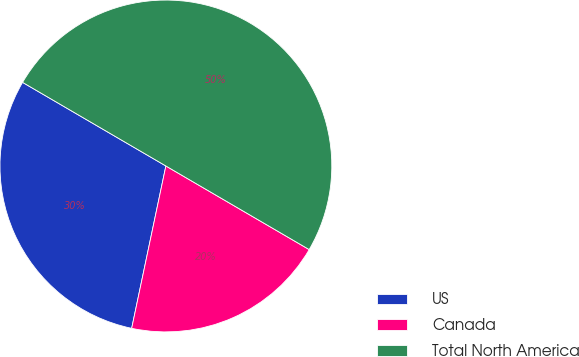<chart> <loc_0><loc_0><loc_500><loc_500><pie_chart><fcel>US<fcel>Canada<fcel>Total North America<nl><fcel>30.1%<fcel>19.9%<fcel>50.0%<nl></chart> 